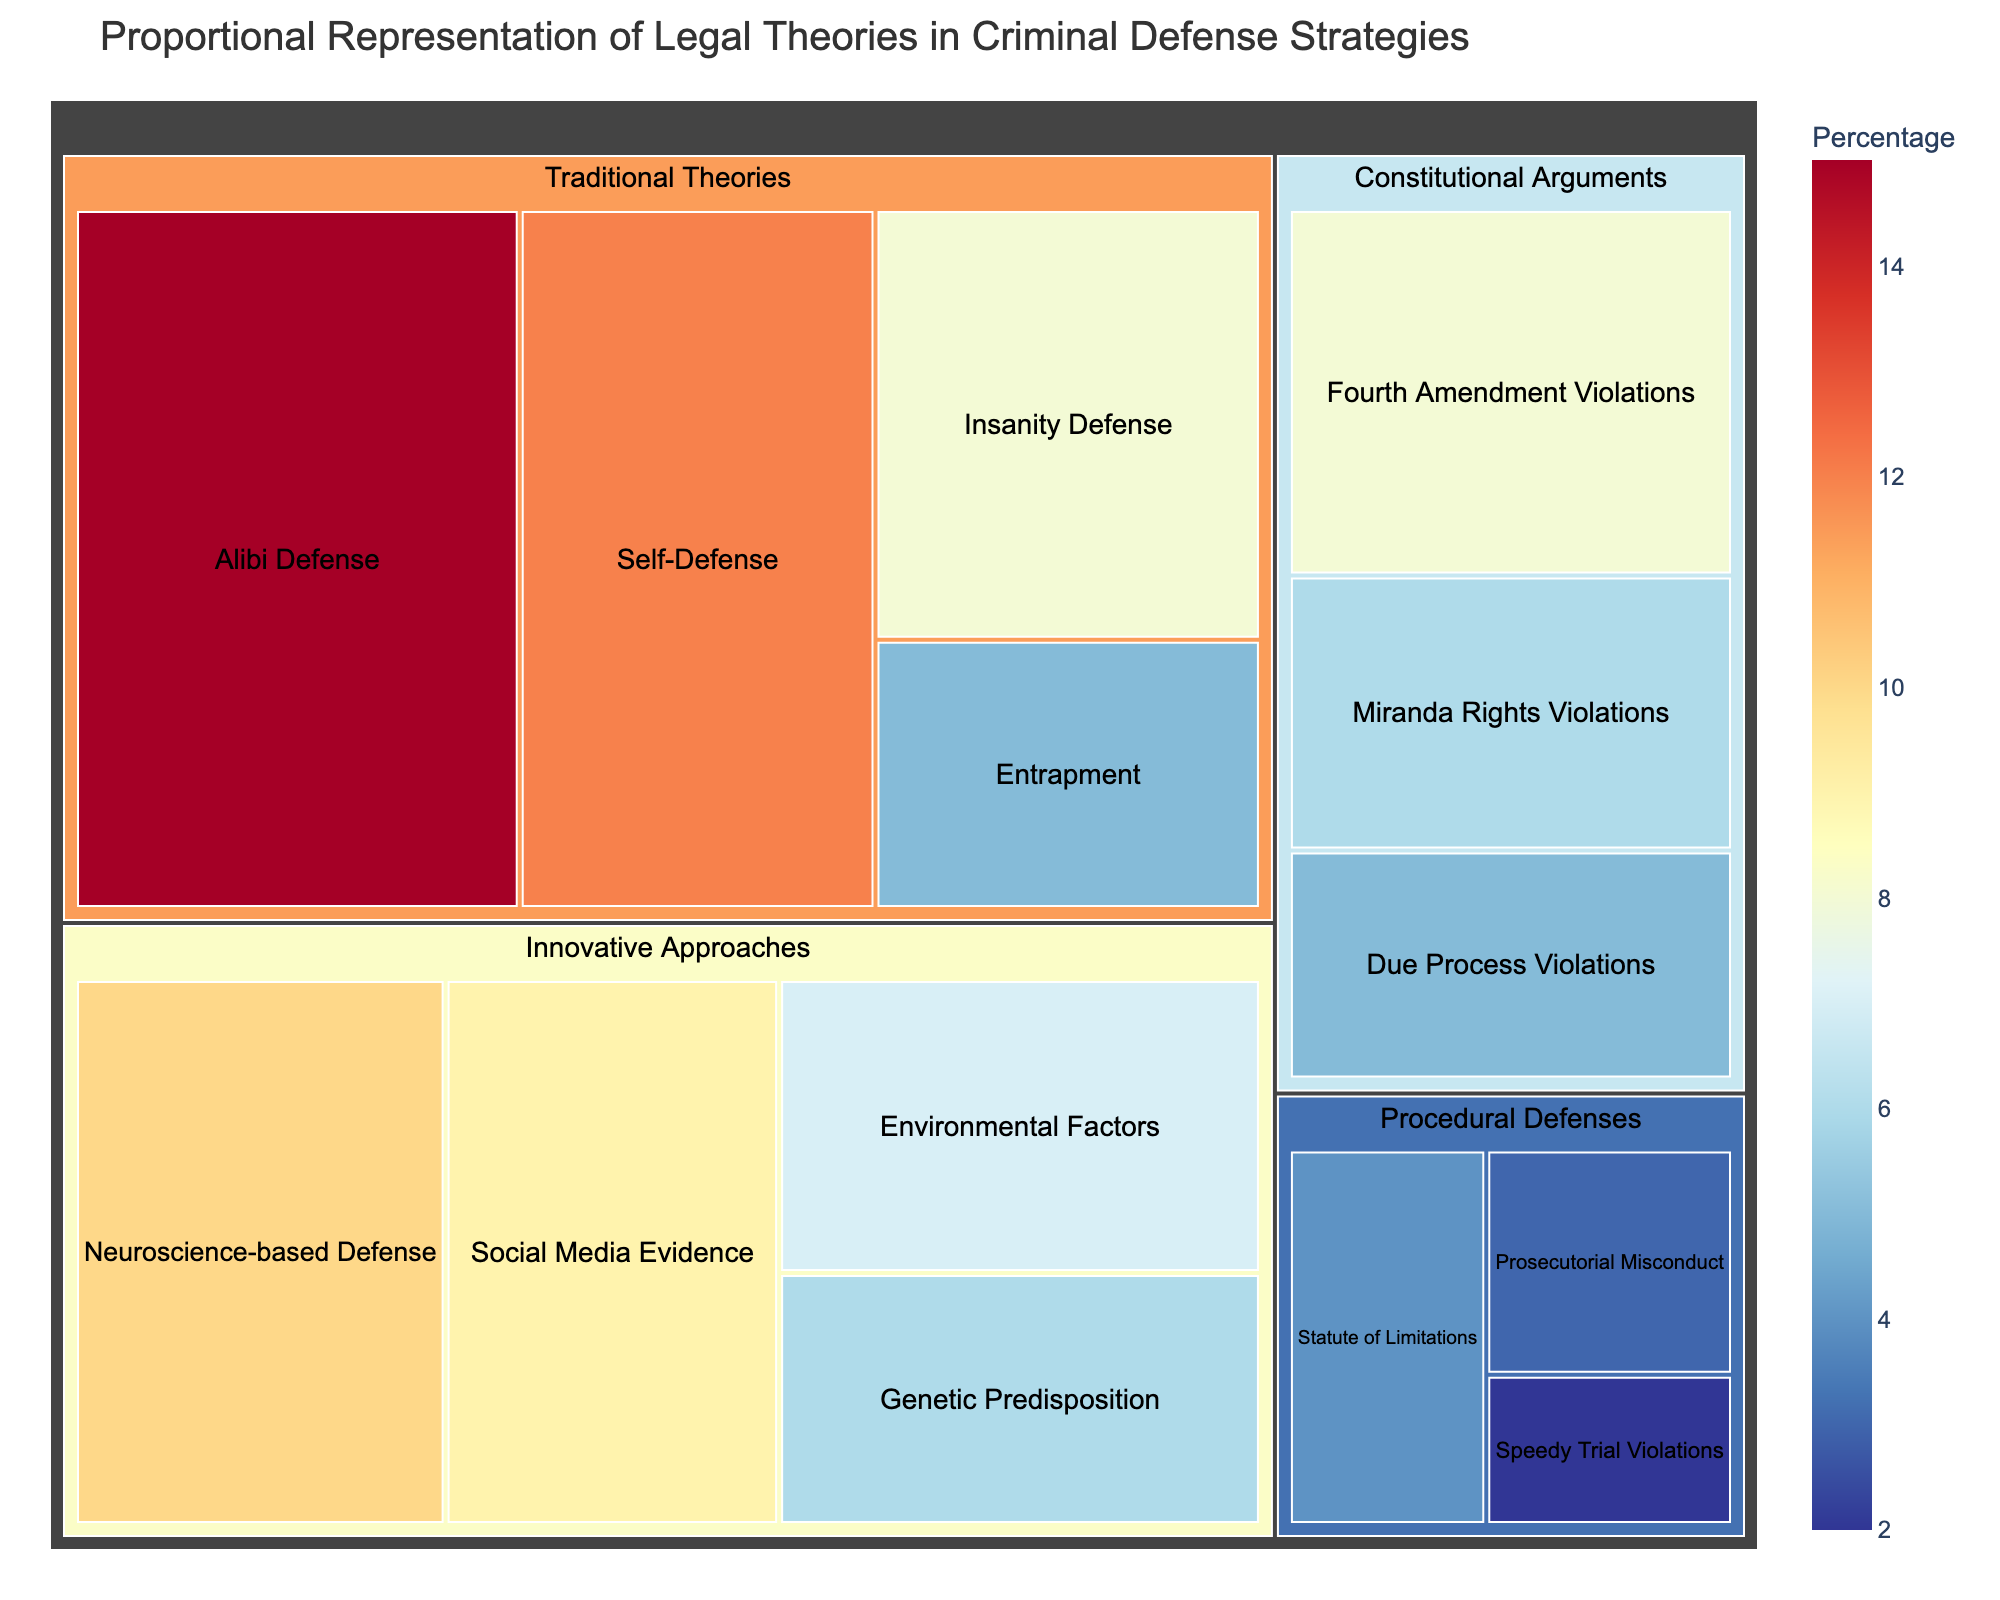what is the title of the figure? The title of the Treemap is located at the top of the figure and is generally set to give an overall description of the visualization.
Answer: Proportional Representation of Legal Theories in Criminal Defense Strategies How many theory categories are represented? Looking at the figure, there are distinct colored sections that indicate different categories. Each section should be counted individually.
Answer: Four Which individual theory has the highest percentage representation? By looking at the sizes of the individual segments and their associated percentages, the largest segment will indicate the highest percentage.
Answer: Alibi Defense What's the combined percentage of genetic predisposition and environmental factors? The percentages for Genetic Predisposition and Environmental Factors can be added together: 6% + 7% = 13%.
Answer: 13% How does the percentage of social media evidence compare to self-defense? Comparing the numeric values associated with Social Media Evidence (9%) and Self-Defense (12%) will show their difference. 12% is greater than 9%.
Answer: Self-Defense is greater Which category has the largest combined percentage? Summing the individual percentages within each category will help determine the largest total. Traditional Theories have the highest sum: 15 + 12 + 8 + 5 = 40%.
Answer: Traditional Theories What's the combined percentage of all theories under Constitutional Arguments? Add the percentages for Fourth Amendment Violations, Miranda Rights Violations, and Due Process Violations: 8% + 6% + 5% = 19%.
Answer: 19% How does the percentage representation of neuroscience-based defense compare to insanity defense? Looking at the individual percentages: Neuroscience-based Defense 10%, Insanity Defense 8%, we see 10% is greater than 8%.
Answer: Neuroscience-based Defense is greater What’s the percentage difference between the highest and lowest represented theories? The highest represented theory is Alibi Defense (15%) and the lowest is Speedy Trial Violations (2%), so the difference is 15% - 2% = 13%.
Answer: 13% How many theories fall under procedural defenses and what is their combined percentage? By counting and summing the related segments: Statute of Limitations (4%), Prosecutorial Misconduct (3%), Speedy Trial Violations (2%) make three theories with a total of 4 + 3 + 2 = 9%.
Answer: Three theories and 9% 